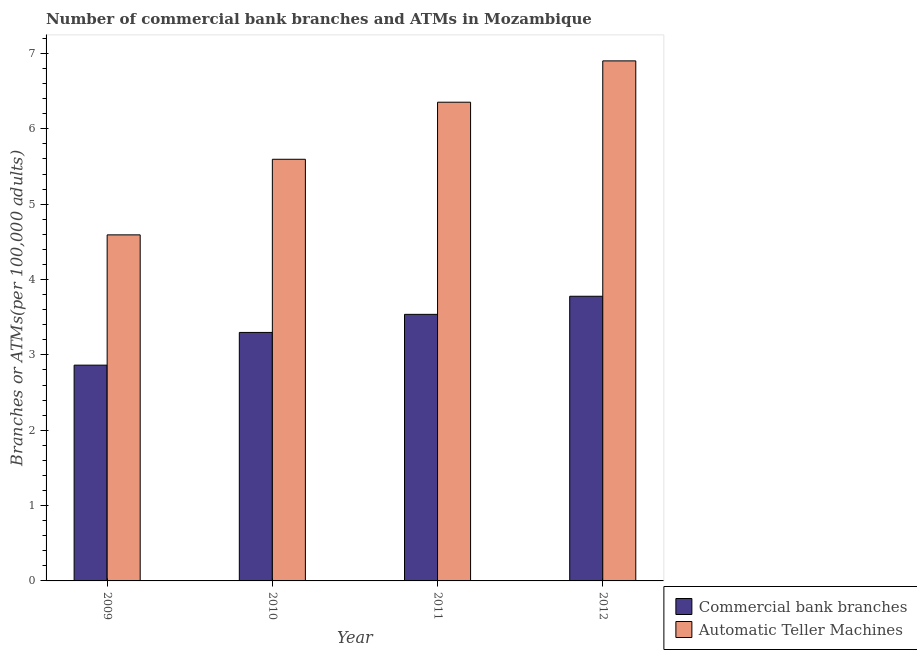How many different coloured bars are there?
Ensure brevity in your answer.  2. How many groups of bars are there?
Offer a very short reply. 4. What is the number of atms in 2012?
Offer a very short reply. 6.9. Across all years, what is the maximum number of commercal bank branches?
Ensure brevity in your answer.  3.78. Across all years, what is the minimum number of atms?
Offer a very short reply. 4.59. In which year was the number of atms maximum?
Make the answer very short. 2012. What is the total number of atms in the graph?
Offer a very short reply. 23.44. What is the difference between the number of commercal bank branches in 2011 and that in 2012?
Your answer should be compact. -0.24. What is the difference between the number of commercal bank branches in 2011 and the number of atms in 2009?
Provide a short and direct response. 0.67. What is the average number of commercal bank branches per year?
Give a very brief answer. 3.37. What is the ratio of the number of commercal bank branches in 2009 to that in 2010?
Provide a succinct answer. 0.87. Is the number of atms in 2009 less than that in 2010?
Your response must be concise. Yes. What is the difference between the highest and the second highest number of atms?
Provide a short and direct response. 0.55. What is the difference between the highest and the lowest number of commercal bank branches?
Your answer should be very brief. 0.91. Is the sum of the number of commercal bank branches in 2010 and 2011 greater than the maximum number of atms across all years?
Offer a very short reply. Yes. What does the 2nd bar from the left in 2011 represents?
Give a very brief answer. Automatic Teller Machines. What does the 2nd bar from the right in 2010 represents?
Give a very brief answer. Commercial bank branches. How many years are there in the graph?
Provide a short and direct response. 4. What is the difference between two consecutive major ticks on the Y-axis?
Offer a terse response. 1. Does the graph contain grids?
Provide a short and direct response. No. How many legend labels are there?
Offer a very short reply. 2. What is the title of the graph?
Provide a succinct answer. Number of commercial bank branches and ATMs in Mozambique. What is the label or title of the Y-axis?
Your answer should be compact. Branches or ATMs(per 100,0 adults). What is the Branches or ATMs(per 100,000 adults) of Commercial bank branches in 2009?
Your answer should be compact. 2.86. What is the Branches or ATMs(per 100,000 adults) of Automatic Teller Machines in 2009?
Your answer should be very brief. 4.59. What is the Branches or ATMs(per 100,000 adults) in Commercial bank branches in 2010?
Give a very brief answer. 3.3. What is the Branches or ATMs(per 100,000 adults) of Automatic Teller Machines in 2010?
Your answer should be very brief. 5.6. What is the Branches or ATMs(per 100,000 adults) of Commercial bank branches in 2011?
Your answer should be very brief. 3.54. What is the Branches or ATMs(per 100,000 adults) in Automatic Teller Machines in 2011?
Provide a succinct answer. 6.35. What is the Branches or ATMs(per 100,000 adults) in Commercial bank branches in 2012?
Provide a short and direct response. 3.78. What is the Branches or ATMs(per 100,000 adults) in Automatic Teller Machines in 2012?
Provide a short and direct response. 6.9. Across all years, what is the maximum Branches or ATMs(per 100,000 adults) of Commercial bank branches?
Make the answer very short. 3.78. Across all years, what is the maximum Branches or ATMs(per 100,000 adults) of Automatic Teller Machines?
Give a very brief answer. 6.9. Across all years, what is the minimum Branches or ATMs(per 100,000 adults) in Commercial bank branches?
Provide a succinct answer. 2.86. Across all years, what is the minimum Branches or ATMs(per 100,000 adults) of Automatic Teller Machines?
Keep it short and to the point. 4.59. What is the total Branches or ATMs(per 100,000 adults) in Commercial bank branches in the graph?
Provide a short and direct response. 13.48. What is the total Branches or ATMs(per 100,000 adults) of Automatic Teller Machines in the graph?
Offer a terse response. 23.44. What is the difference between the Branches or ATMs(per 100,000 adults) of Commercial bank branches in 2009 and that in 2010?
Offer a terse response. -0.43. What is the difference between the Branches or ATMs(per 100,000 adults) in Automatic Teller Machines in 2009 and that in 2010?
Offer a terse response. -1. What is the difference between the Branches or ATMs(per 100,000 adults) of Commercial bank branches in 2009 and that in 2011?
Ensure brevity in your answer.  -0.67. What is the difference between the Branches or ATMs(per 100,000 adults) of Automatic Teller Machines in 2009 and that in 2011?
Make the answer very short. -1.76. What is the difference between the Branches or ATMs(per 100,000 adults) in Commercial bank branches in 2009 and that in 2012?
Provide a short and direct response. -0.91. What is the difference between the Branches or ATMs(per 100,000 adults) of Automatic Teller Machines in 2009 and that in 2012?
Your answer should be compact. -2.31. What is the difference between the Branches or ATMs(per 100,000 adults) of Commercial bank branches in 2010 and that in 2011?
Your response must be concise. -0.24. What is the difference between the Branches or ATMs(per 100,000 adults) in Automatic Teller Machines in 2010 and that in 2011?
Offer a terse response. -0.76. What is the difference between the Branches or ATMs(per 100,000 adults) of Commercial bank branches in 2010 and that in 2012?
Ensure brevity in your answer.  -0.48. What is the difference between the Branches or ATMs(per 100,000 adults) of Automatic Teller Machines in 2010 and that in 2012?
Provide a succinct answer. -1.31. What is the difference between the Branches or ATMs(per 100,000 adults) in Commercial bank branches in 2011 and that in 2012?
Provide a short and direct response. -0.24. What is the difference between the Branches or ATMs(per 100,000 adults) of Automatic Teller Machines in 2011 and that in 2012?
Your answer should be very brief. -0.55. What is the difference between the Branches or ATMs(per 100,000 adults) of Commercial bank branches in 2009 and the Branches or ATMs(per 100,000 adults) of Automatic Teller Machines in 2010?
Provide a short and direct response. -2.73. What is the difference between the Branches or ATMs(per 100,000 adults) in Commercial bank branches in 2009 and the Branches or ATMs(per 100,000 adults) in Automatic Teller Machines in 2011?
Your answer should be very brief. -3.49. What is the difference between the Branches or ATMs(per 100,000 adults) of Commercial bank branches in 2009 and the Branches or ATMs(per 100,000 adults) of Automatic Teller Machines in 2012?
Provide a short and direct response. -4.04. What is the difference between the Branches or ATMs(per 100,000 adults) of Commercial bank branches in 2010 and the Branches or ATMs(per 100,000 adults) of Automatic Teller Machines in 2011?
Your response must be concise. -3.06. What is the difference between the Branches or ATMs(per 100,000 adults) of Commercial bank branches in 2010 and the Branches or ATMs(per 100,000 adults) of Automatic Teller Machines in 2012?
Your answer should be very brief. -3.6. What is the difference between the Branches or ATMs(per 100,000 adults) of Commercial bank branches in 2011 and the Branches or ATMs(per 100,000 adults) of Automatic Teller Machines in 2012?
Provide a succinct answer. -3.36. What is the average Branches or ATMs(per 100,000 adults) of Commercial bank branches per year?
Your answer should be very brief. 3.37. What is the average Branches or ATMs(per 100,000 adults) in Automatic Teller Machines per year?
Offer a very short reply. 5.86. In the year 2009, what is the difference between the Branches or ATMs(per 100,000 adults) in Commercial bank branches and Branches or ATMs(per 100,000 adults) in Automatic Teller Machines?
Keep it short and to the point. -1.73. In the year 2010, what is the difference between the Branches or ATMs(per 100,000 adults) of Commercial bank branches and Branches or ATMs(per 100,000 adults) of Automatic Teller Machines?
Your answer should be compact. -2.3. In the year 2011, what is the difference between the Branches or ATMs(per 100,000 adults) in Commercial bank branches and Branches or ATMs(per 100,000 adults) in Automatic Teller Machines?
Ensure brevity in your answer.  -2.82. In the year 2012, what is the difference between the Branches or ATMs(per 100,000 adults) in Commercial bank branches and Branches or ATMs(per 100,000 adults) in Automatic Teller Machines?
Provide a short and direct response. -3.12. What is the ratio of the Branches or ATMs(per 100,000 adults) in Commercial bank branches in 2009 to that in 2010?
Provide a succinct answer. 0.87. What is the ratio of the Branches or ATMs(per 100,000 adults) of Automatic Teller Machines in 2009 to that in 2010?
Your answer should be compact. 0.82. What is the ratio of the Branches or ATMs(per 100,000 adults) of Commercial bank branches in 2009 to that in 2011?
Give a very brief answer. 0.81. What is the ratio of the Branches or ATMs(per 100,000 adults) in Automatic Teller Machines in 2009 to that in 2011?
Your answer should be very brief. 0.72. What is the ratio of the Branches or ATMs(per 100,000 adults) in Commercial bank branches in 2009 to that in 2012?
Provide a short and direct response. 0.76. What is the ratio of the Branches or ATMs(per 100,000 adults) of Automatic Teller Machines in 2009 to that in 2012?
Give a very brief answer. 0.67. What is the ratio of the Branches or ATMs(per 100,000 adults) of Commercial bank branches in 2010 to that in 2011?
Your response must be concise. 0.93. What is the ratio of the Branches or ATMs(per 100,000 adults) in Automatic Teller Machines in 2010 to that in 2011?
Offer a very short reply. 0.88. What is the ratio of the Branches or ATMs(per 100,000 adults) of Commercial bank branches in 2010 to that in 2012?
Provide a succinct answer. 0.87. What is the ratio of the Branches or ATMs(per 100,000 adults) in Automatic Teller Machines in 2010 to that in 2012?
Give a very brief answer. 0.81. What is the ratio of the Branches or ATMs(per 100,000 adults) in Commercial bank branches in 2011 to that in 2012?
Your response must be concise. 0.94. What is the ratio of the Branches or ATMs(per 100,000 adults) in Automatic Teller Machines in 2011 to that in 2012?
Your answer should be compact. 0.92. What is the difference between the highest and the second highest Branches or ATMs(per 100,000 adults) of Commercial bank branches?
Ensure brevity in your answer.  0.24. What is the difference between the highest and the second highest Branches or ATMs(per 100,000 adults) in Automatic Teller Machines?
Your response must be concise. 0.55. What is the difference between the highest and the lowest Branches or ATMs(per 100,000 adults) of Commercial bank branches?
Provide a short and direct response. 0.91. What is the difference between the highest and the lowest Branches or ATMs(per 100,000 adults) of Automatic Teller Machines?
Make the answer very short. 2.31. 